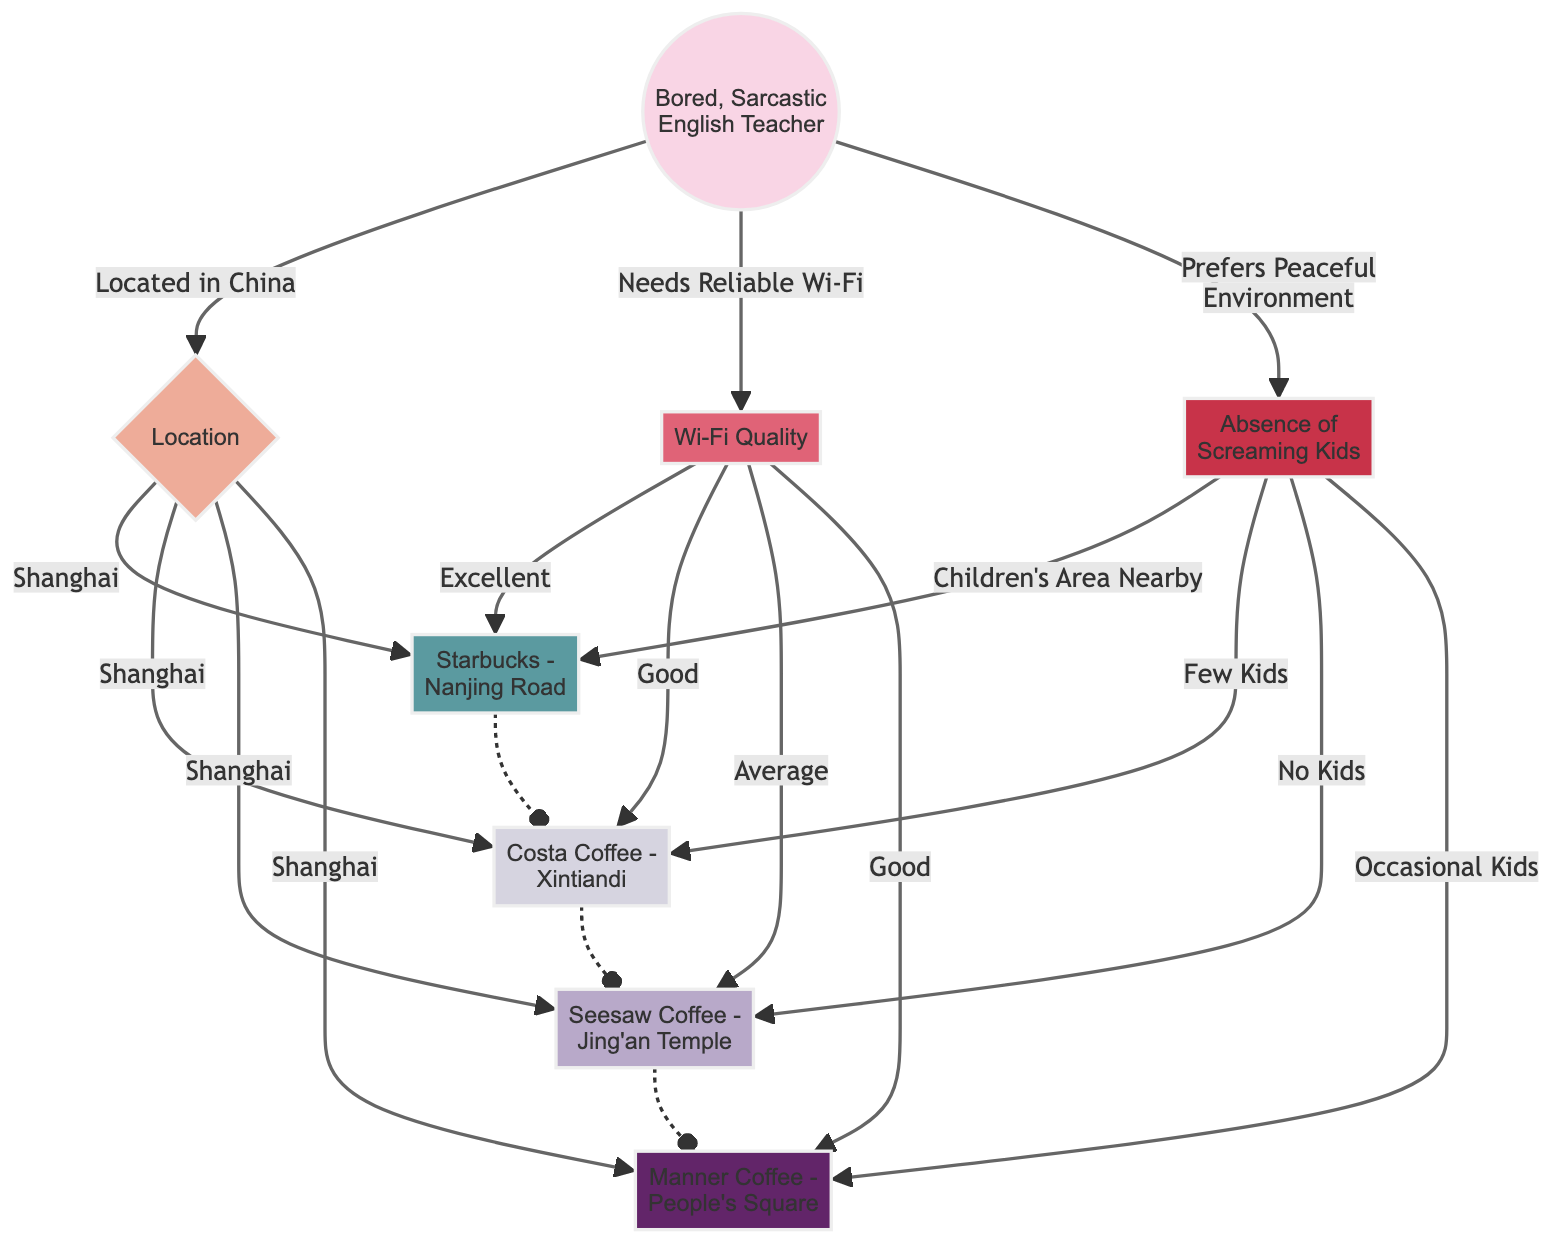What is the label of the node with ID "teacher"? The diagram shows the node with ID "teacher" labeled as "Bored, Sarcastic English Teacher".
Answer: Bored, Sarcastic English Teacher How many coffee shops are represented in this diagram? Counting the coffee shop nodes, there are four labeled nodes, which are Starbucks, Costa Coffee, Seesaw Coffee, and Manner Coffee.
Answer: 4 What is the Wi-Fi quality at COFFEE SHOP3? The edge from the "Wi-Fi Quality" node to "Seesaw Coffee - Jing'an Temple" indicates that the Wi-Fi quality is "Average".
Answer: Average Which coffee shop has "No Kids"? The edge from the "Absence of Screaming Kids" node to "Seesaw Coffee" indicates the absence of kids. Therefore, Seesaw Coffee has "No Kids".
Answer: Seesaw Coffee - Jing'an Temple Which coffee shop is categorized with "Excellent" Wi-Fi? The connection from the "Wi-Fi Quality" to "Starbucks - Nanjing Road" indicates that this coffee shop has "Excellent" Wi-Fi.
Answer: Starbucks - Nanjing Road If a user prefers a peaceful environment and reliable Wi-Fi, which coffee shop is the best option? The best option for reliable Wi-Fi and absence of screaming kids is the coffee shop linked by both edges, which leads to "Seesaw Coffee - Jing'an Temple" as it has "No Kids" and "Average" Wi-Fi. However, realizing the preference for "Excellent" or "Good" Wi-Fi, the best options are Starbucks and Costa Coffee.
Answer: Starbucks - Nanjing Road Which coffee shop has "Few Kids"? The connection from the "Absence of Screaming Kids" indicates that "Costa Coffee - Xintiandi" has "Few Kids".
Answer: Costa Coffee - Xintiandi What does the teacher need based on the diagram? The edge labeled "Needs Reliable Wi-Fi" indicates that the teacher requires good quality Wi-Fi.
Answer: Reliable Wi-Fi In what location are all of the coffee shops situated according to the diagram? All coffee shops in the diagram are connected to the location node labeled as "Shanghai".
Answer: Shanghai 